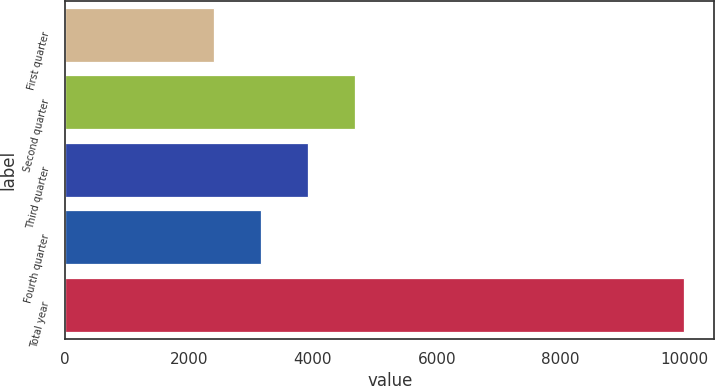Convert chart to OTSL. <chart><loc_0><loc_0><loc_500><loc_500><bar_chart><fcel>First quarter<fcel>Second quarter<fcel>Third quarter<fcel>Fourth quarter<fcel>Total year<nl><fcel>2412.2<fcel>4683.62<fcel>3926.48<fcel>3169.34<fcel>9983.6<nl></chart> 